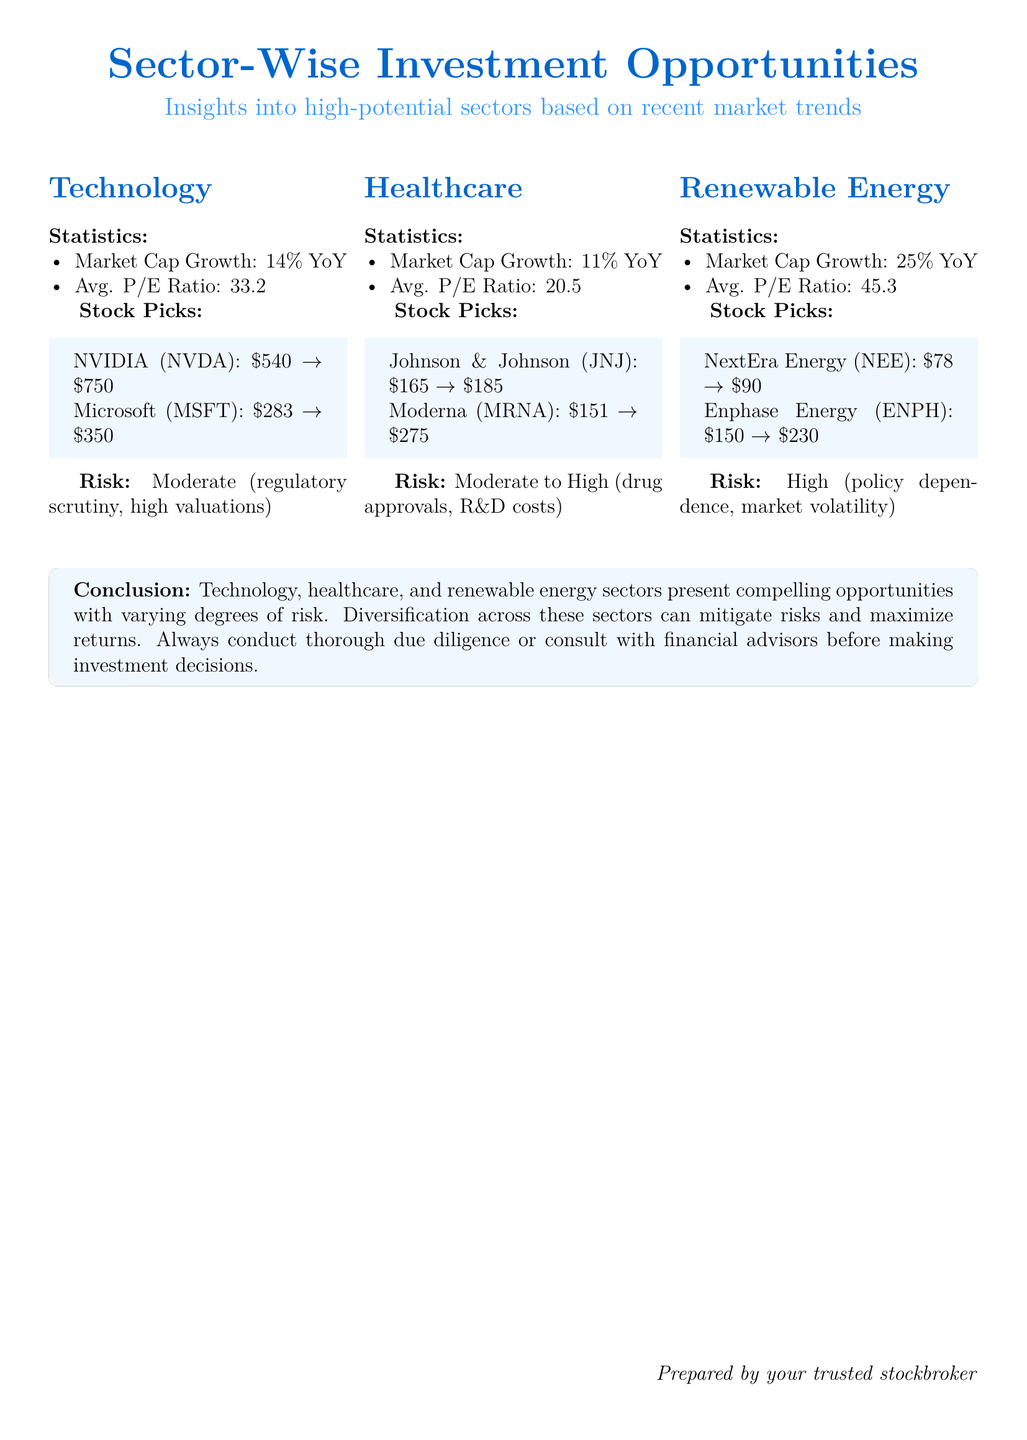What is the market cap growth of the technology sector? The market cap growth for the technology sector is specified as 14% YoY.
Answer: 14% YoY What is the average P/E ratio for the healthcare sector? The document states that the average P/E ratio for the healthcare sector is 20.5.
Answer: 20.5 Which stock is a pick in the renewable energy sector? The renewable energy sector lists NextEra Energy (NEE) as one of its stock picks.
Answer: NextEra Energy (NEE) What is the risk level associated with the renewable energy sector? The risk level for the renewable energy sector is categorized as high due to factors like policy dependence and market volatility.
Answer: High What is the expected price increase for Microsoft? The expected price increase for Microsoft is from 283 to 350.
Answer: \$283 $\rightarrow$ \$350 Which sector had the highest market cap growth? The sector with the highest market cap growth, at 25%, is renewable energy.
Answer: Renewable Energy What does the conclusion suggest about diversification? The conclusion recommends that diversification across sectors can mitigate risks and maximize returns.
Answer: Mitigate risks and maximize returns What is the range of expected price for Moderna? The expected price range for Moderna is from 151 to 275.
Answer: \$151 $\rightarrow$ \$275 